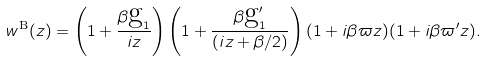Convert formula to latex. <formula><loc_0><loc_0><loc_500><loc_500>w ^ { \text {B} } ( z ) = \left ( 1 + \frac { \beta \text {g} _ { 1 } } { i z } \right ) \left ( 1 + \frac { \beta \text {g} _ { 1 } ^ { \prime } } { ( i z + \beta / 2 ) } \right ) ( 1 + i \beta \varpi z ) ( 1 + i \beta \varpi ^ { \prime } z ) .</formula> 